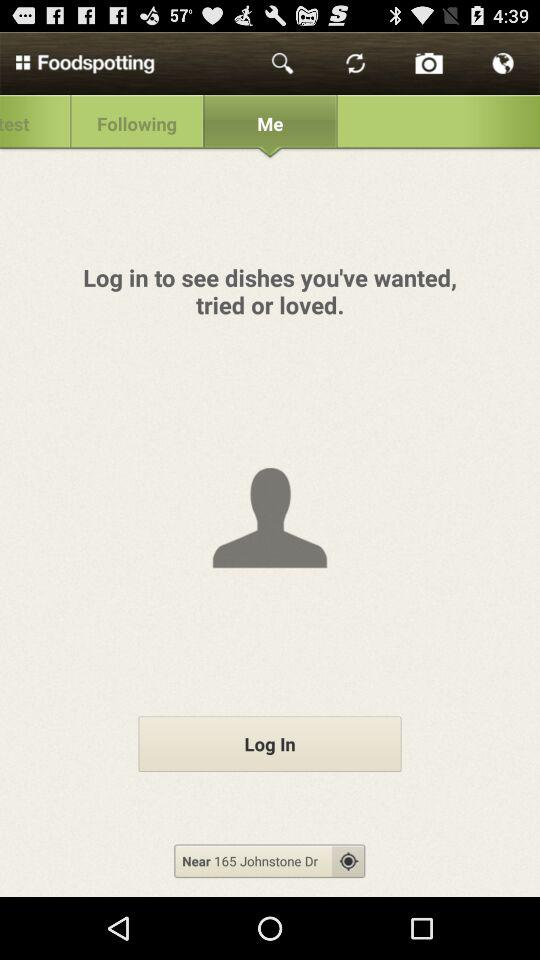What is the application name? The application name is "Foodspotting". 